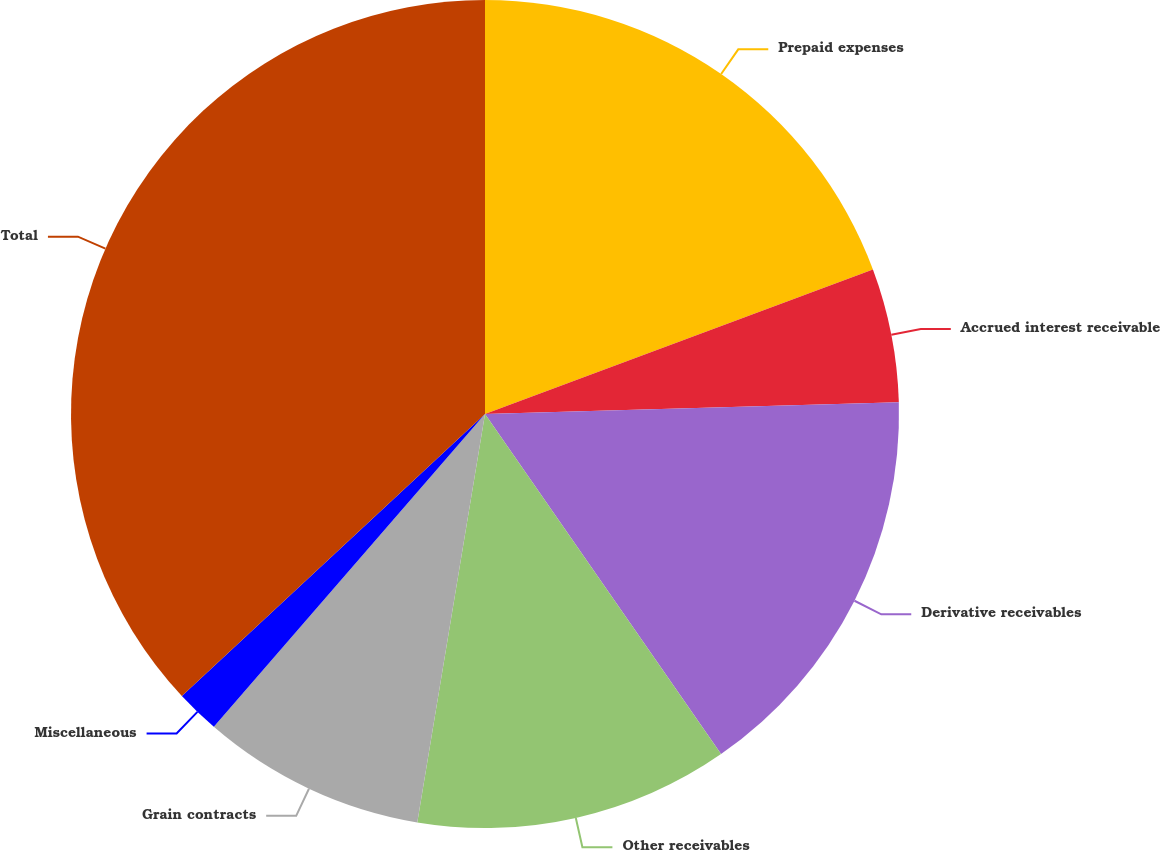Convert chart. <chart><loc_0><loc_0><loc_500><loc_500><pie_chart><fcel>Prepaid expenses<fcel>Accrued interest receivable<fcel>Derivative receivables<fcel>Other receivables<fcel>Grain contracts<fcel>Miscellaneous<fcel>Total<nl><fcel>19.32%<fcel>5.23%<fcel>15.79%<fcel>12.27%<fcel>8.75%<fcel>1.71%<fcel>36.92%<nl></chart> 